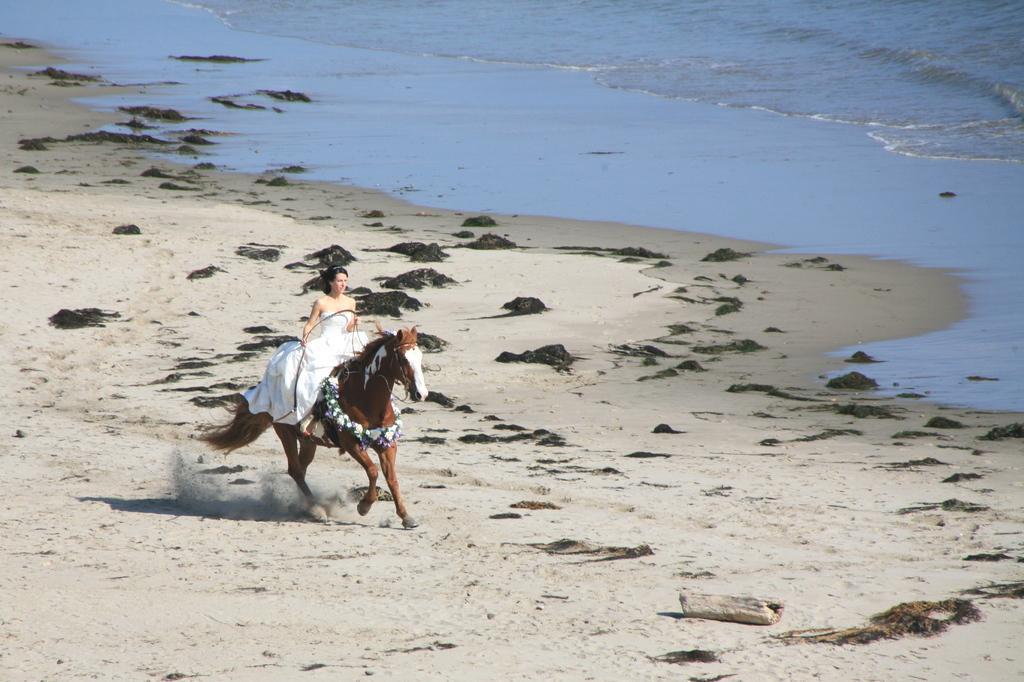Could you give a brief overview of what you see in this image? In this picture there is a woman riding a horse and on to to her left there is a sea. 